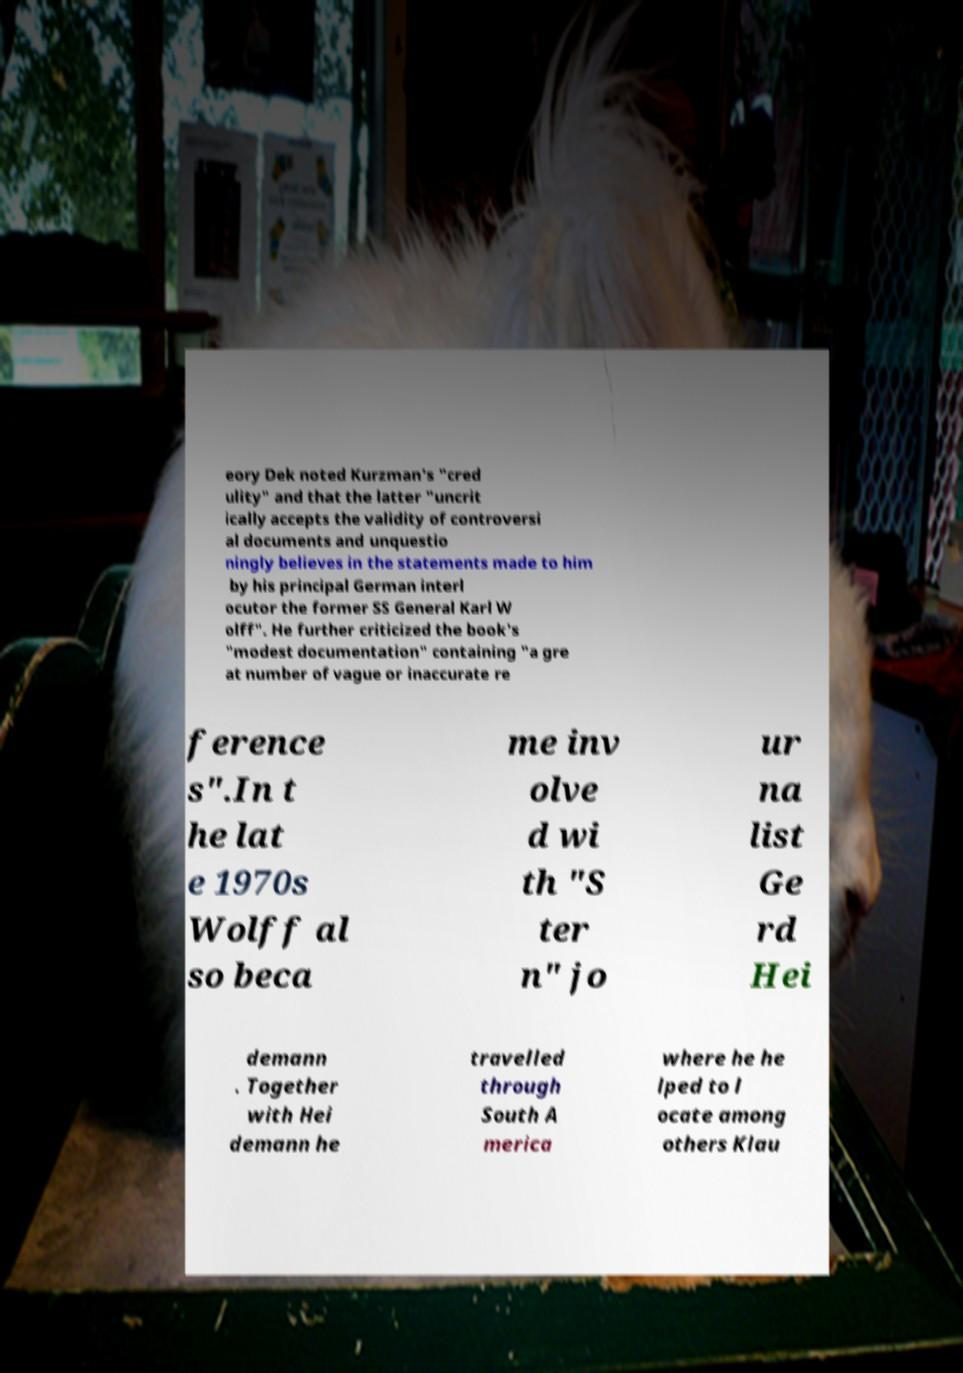Can you accurately transcribe the text from the provided image for me? eory Dek noted Kurzman's "cred ulity" and that the latter "uncrit ically accepts the validity of controversi al documents and unquestio ningly believes in the statements made to him by his principal German interl ocutor the former SS General Karl W olff". He further criticized the book's "modest documentation" containing "a gre at number of vague or inaccurate re ference s".In t he lat e 1970s Wolff al so beca me inv olve d wi th "S ter n" jo ur na list Ge rd Hei demann . Together with Hei demann he travelled through South A merica where he he lped to l ocate among others Klau 